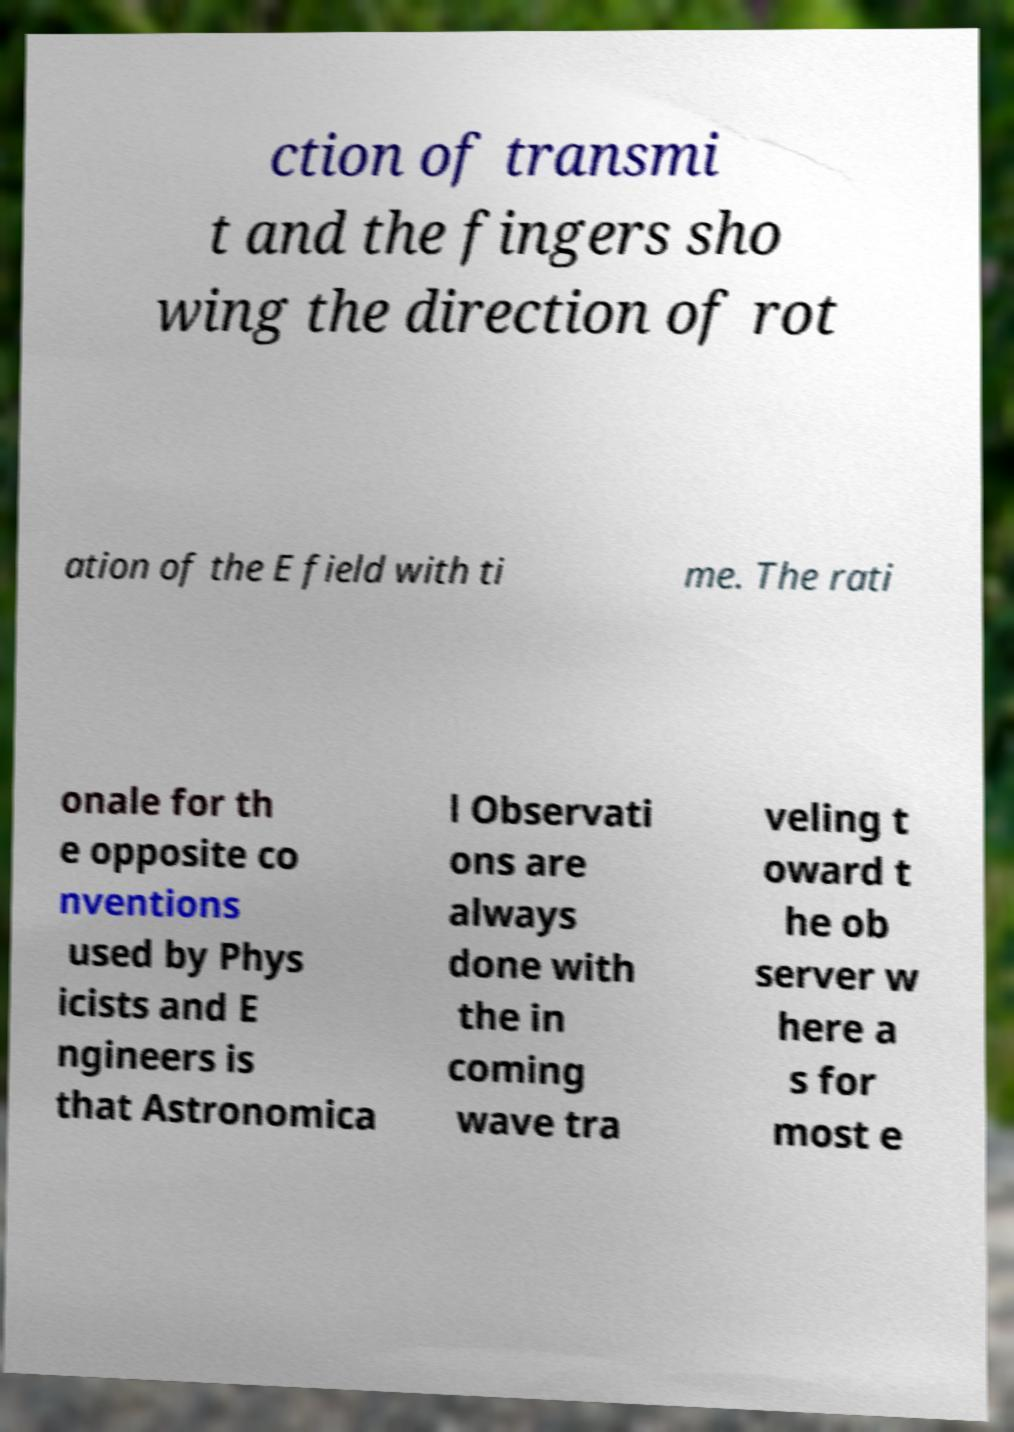Could you extract and type out the text from this image? ction of transmi t and the fingers sho wing the direction of rot ation of the E field with ti me. The rati onale for th e opposite co nventions used by Phys icists and E ngineers is that Astronomica l Observati ons are always done with the in coming wave tra veling t oward t he ob server w here a s for most e 